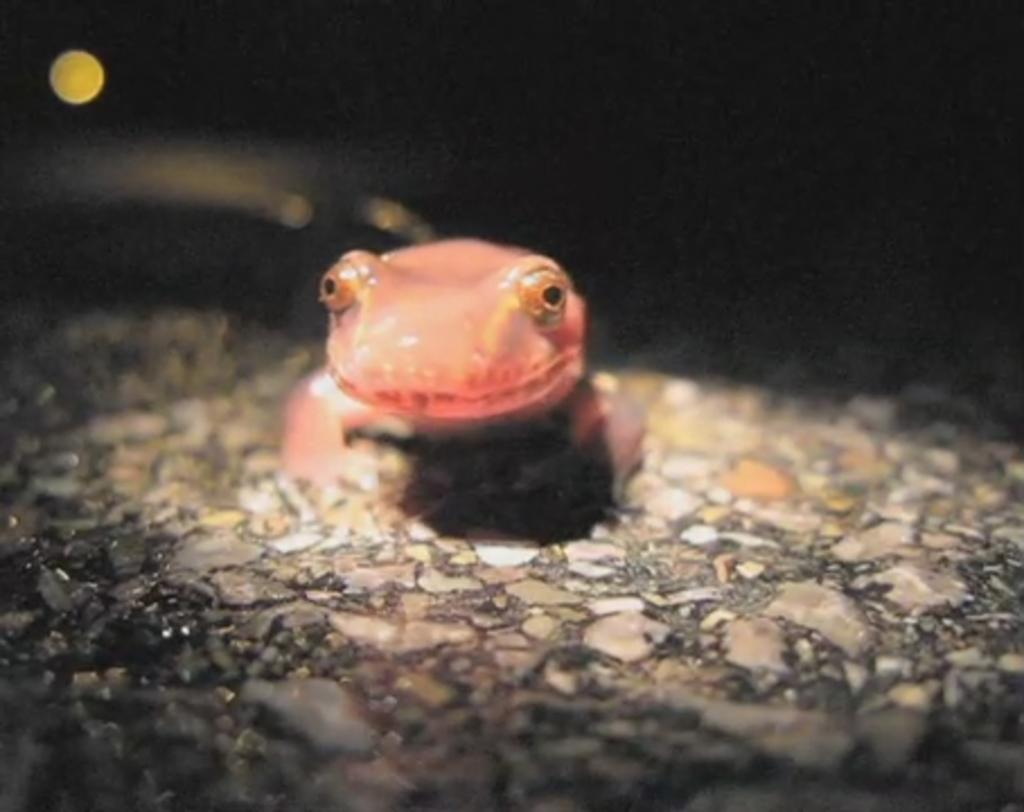What type of animal is in the image? There is a lizard in the image. What is the surface beneath the lizard? There is a floor at the bottom of the image. Where is the light source located in the image? There is a light on the left side of the image. How many ducks are in the flock that is present in the plantation in the image? There are no ducks, flock, or plantation present in the image; it features a lizard and a floor with a light source. 